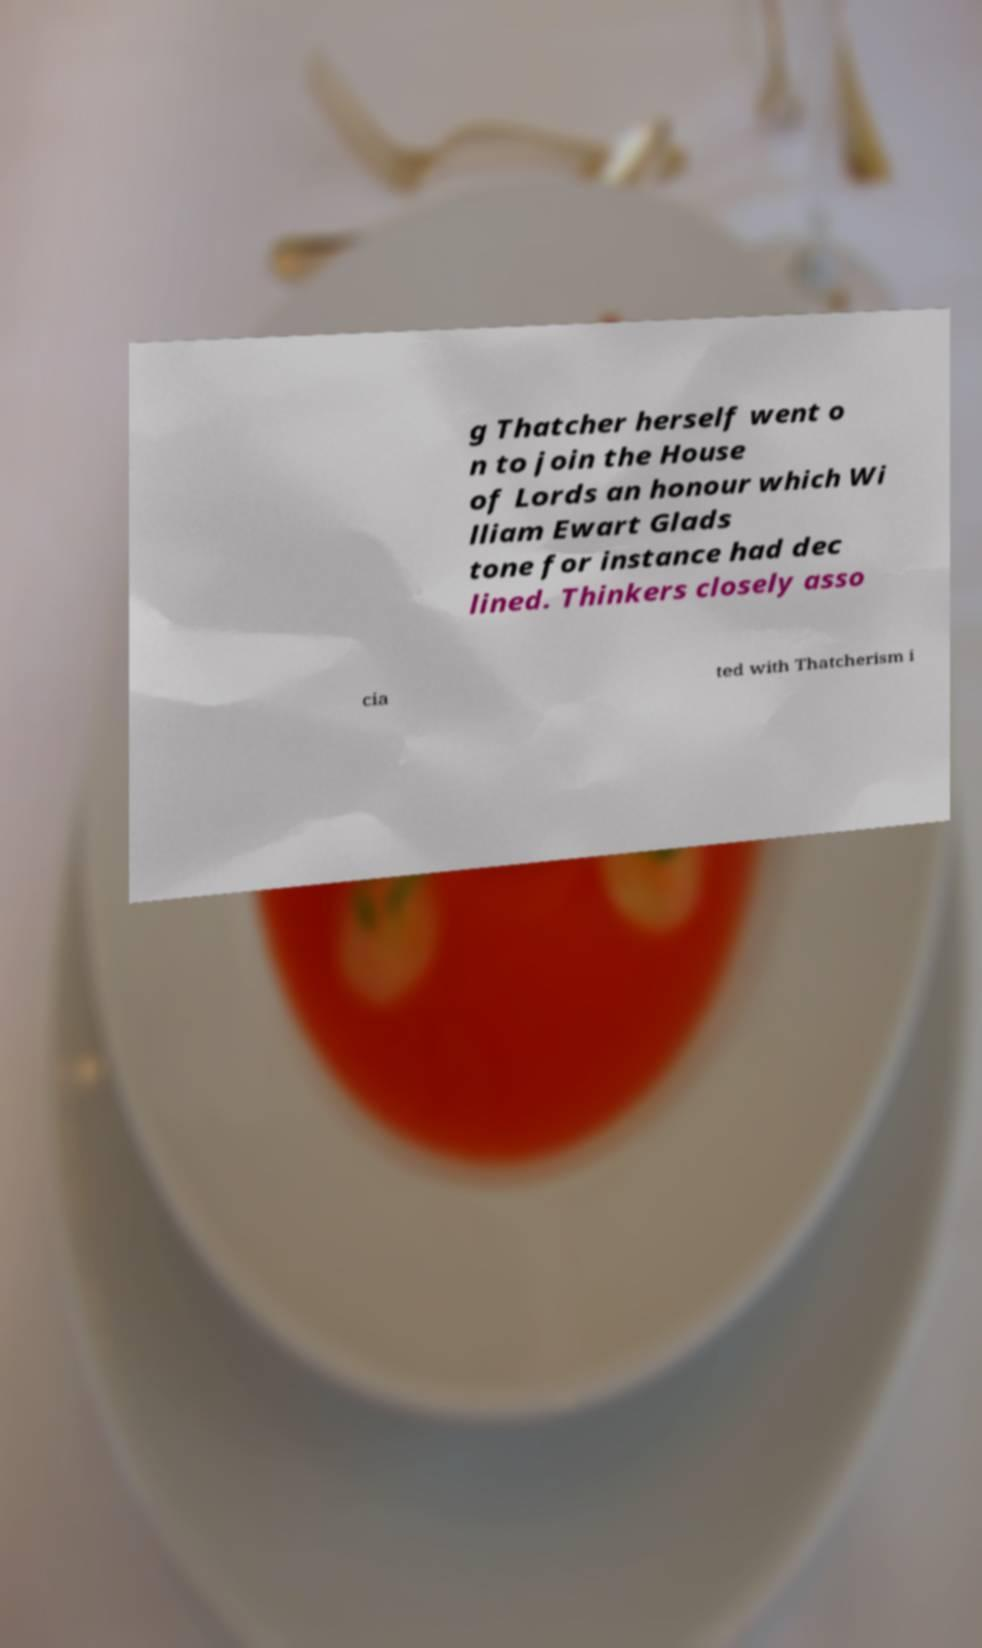What messages or text are displayed in this image? I need them in a readable, typed format. g Thatcher herself went o n to join the House of Lords an honour which Wi lliam Ewart Glads tone for instance had dec lined. Thinkers closely asso cia ted with Thatcherism i 